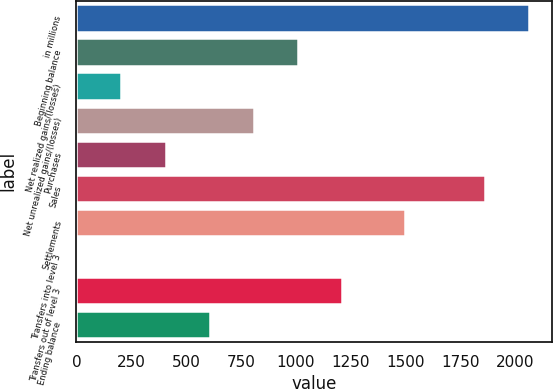Convert chart. <chart><loc_0><loc_0><loc_500><loc_500><bar_chart><fcel>in millions<fcel>Beginning balance<fcel>Net realized gains/(losses)<fcel>Net unrealized gains/(losses)<fcel>Purchases<fcel>Sales<fcel>Settlements<fcel>Transfers into level 3<fcel>Transfers out of level 3<fcel>Ending balance<nl><fcel>2065.1<fcel>1009.5<fcel>205.1<fcel>808.4<fcel>406.2<fcel>1864<fcel>1498<fcel>4<fcel>1210.6<fcel>607.3<nl></chart> 